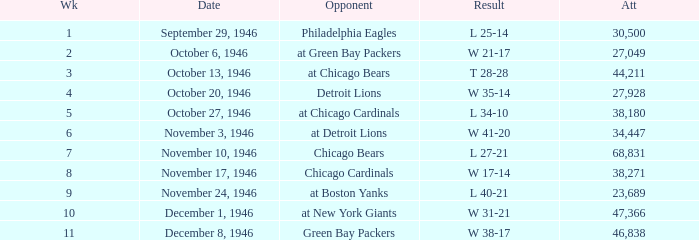What is the combined attendance of all games that had a result of w 35-14? 27928.0. 